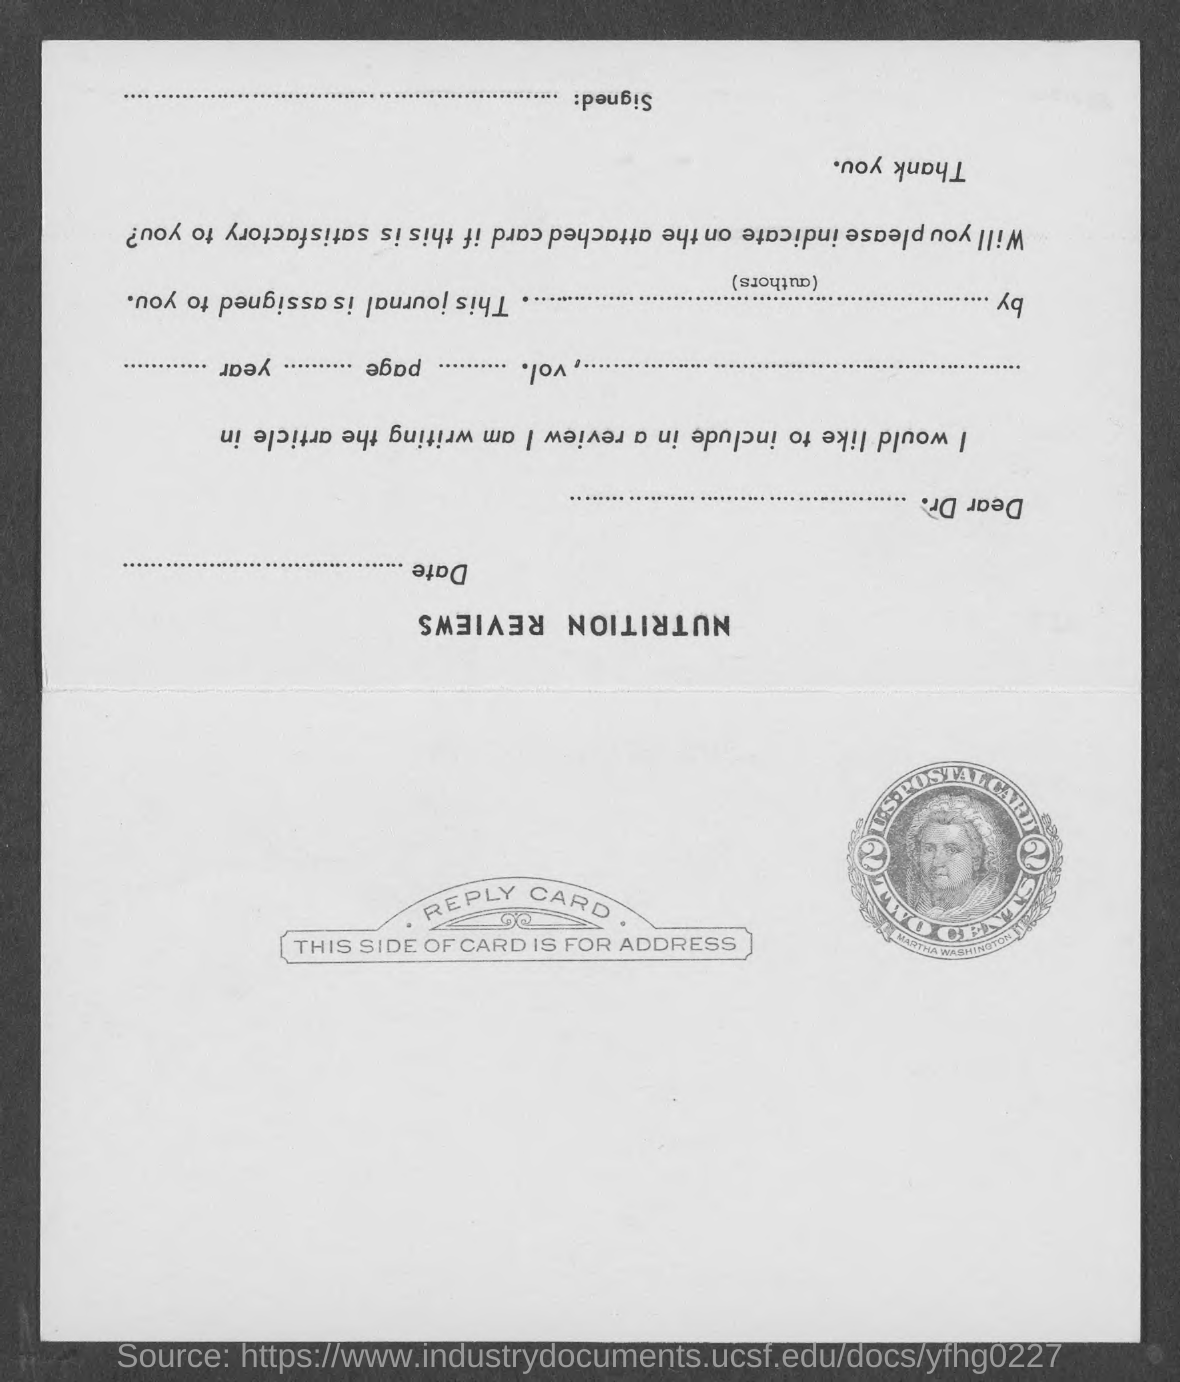List a handful of essential elements in this visual. The women depicted on the postal stamp is named Martha Washington. The post card belongs to the United States. 